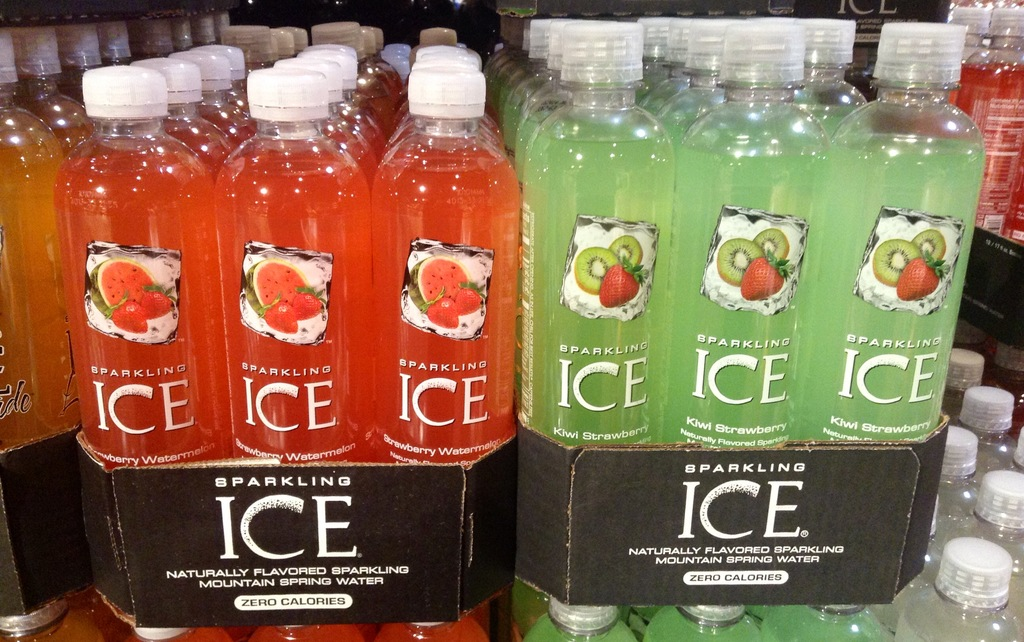How does the product labeling contribute to its marketing? The product labeling features bold and colorful fruit images which effectively communicate the natural flavor offerings and attract attention, while the clear mention of 'Zero Calories' caters to health-conscious consumers. Is there any information on the source of water used in these drinks? Yes, the label mentions it's made with 'Naturally Flavored Mountain Spring Water,' highlighting the purity and quality of the water source which could reassure consumers about the product's health benefits. 